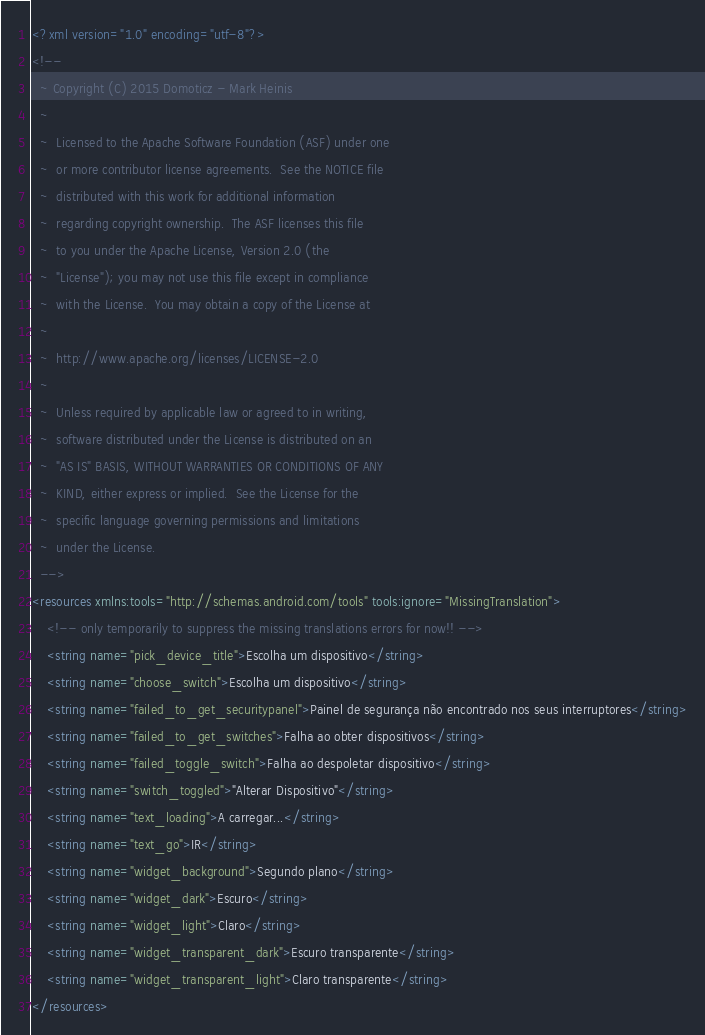<code> <loc_0><loc_0><loc_500><loc_500><_XML_><?xml version="1.0" encoding="utf-8"?>
<!--
  ~ Copyright (C) 2015 Domoticz - Mark Heinis
  ~
  ~  Licensed to the Apache Software Foundation (ASF) under one
  ~  or more contributor license agreements.  See the NOTICE file
  ~  distributed with this work for additional information
  ~  regarding copyright ownership.  The ASF licenses this file
  ~  to you under the Apache License, Version 2.0 (the
  ~  "License"); you may not use this file except in compliance
  ~  with the License.  You may obtain a copy of the License at
  ~
  ~  http://www.apache.org/licenses/LICENSE-2.0
  ~
  ~  Unless required by applicable law or agreed to in writing,
  ~  software distributed under the License is distributed on an
  ~  "AS IS" BASIS, WITHOUT WARRANTIES OR CONDITIONS OF ANY
  ~  KIND, either express or implied.  See the License for the
  ~  specific language governing permissions and limitations
  ~  under the License.
  -->
<resources xmlns:tools="http://schemas.android.com/tools" tools:ignore="MissingTranslation">
    <!-- only temporarily to suppress the missing translations errors for now!! -->
    <string name="pick_device_title">Escolha um dispositivo</string>
    <string name="choose_switch">Escolha um dispositivo</string>
    <string name="failed_to_get_securitypanel">Painel de segurança não encontrado nos seus interruptores</string>
    <string name="failed_to_get_switches">Falha ao obter dispositivos</string>
    <string name="failed_toggle_switch">Falha ao despoletar dispositivo</string>
    <string name="switch_toggled">"Alterar Dispositivo"</string>
    <string name="text_loading">A carregar...</string>
    <string name="text_go">IR</string>
    <string name="widget_background">Segundo plano</string>
    <string name="widget_dark">Escuro</string>
    <string name="widget_light">Claro</string>
    <string name="widget_transparent_dark">Escuro transparente</string>
    <string name="widget_transparent_light">Claro transparente</string>
</resources>
</code> 